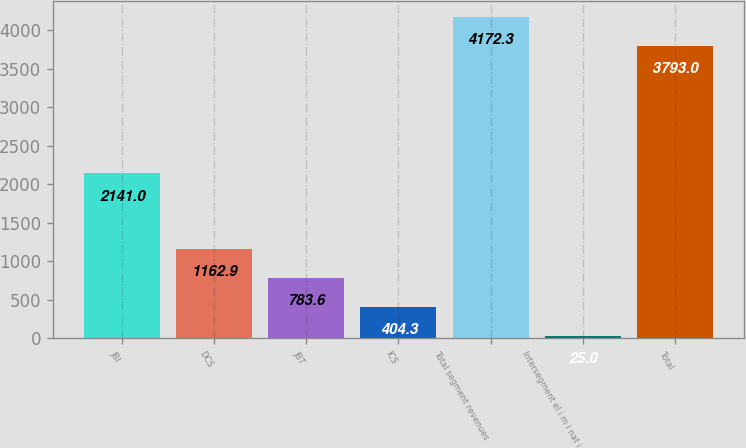Convert chart. <chart><loc_0><loc_0><loc_500><loc_500><bar_chart><fcel>JBI<fcel>DCS<fcel>JBT<fcel>ICS<fcel>Total segment revenues<fcel>Intersegment el i m i nat i<fcel>Total<nl><fcel>2141<fcel>1162.9<fcel>783.6<fcel>404.3<fcel>4172.3<fcel>25<fcel>3793<nl></chart> 